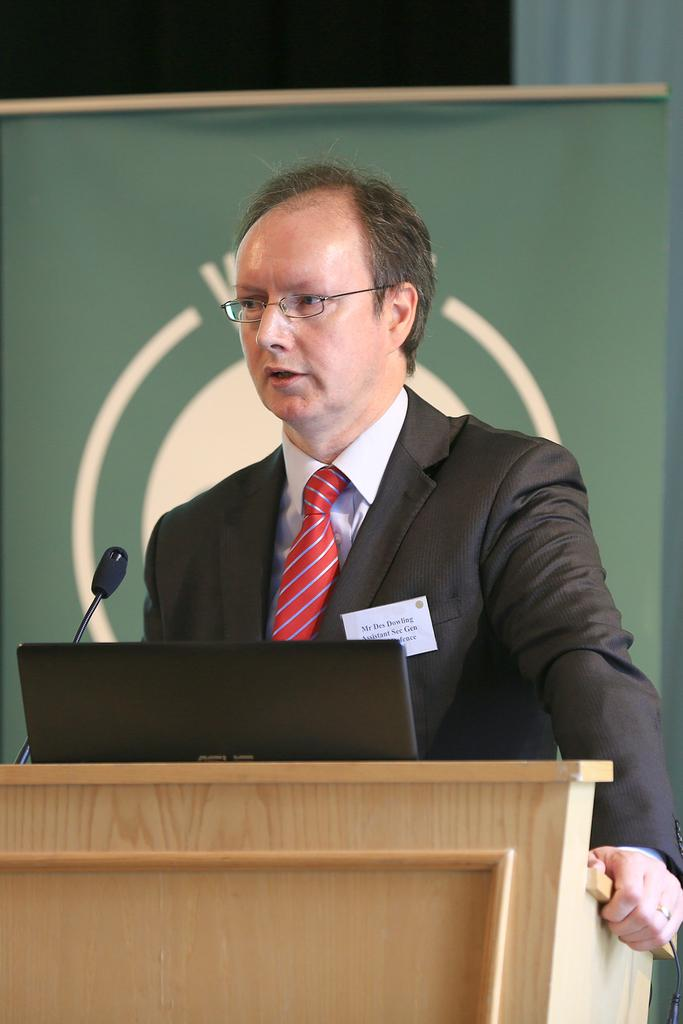What is the person in the image doing? The person is standing in front of a podium. What is the person holding in the image? The person is holding a mic. What is on the podium in the image? There is a laptop on the podium. What is the person wearing in the image? The person is wearing a black coat and a red tie. What color is the banner in the background of the image? The banner in the background is green. What type of amusement park ride is visible in the image? There is no amusement park ride present in the image; it features a person standing in front of a podium with a laptop and a mic. What account number is associated with the person in the image? There is no account number mentioned or visible in the image. 